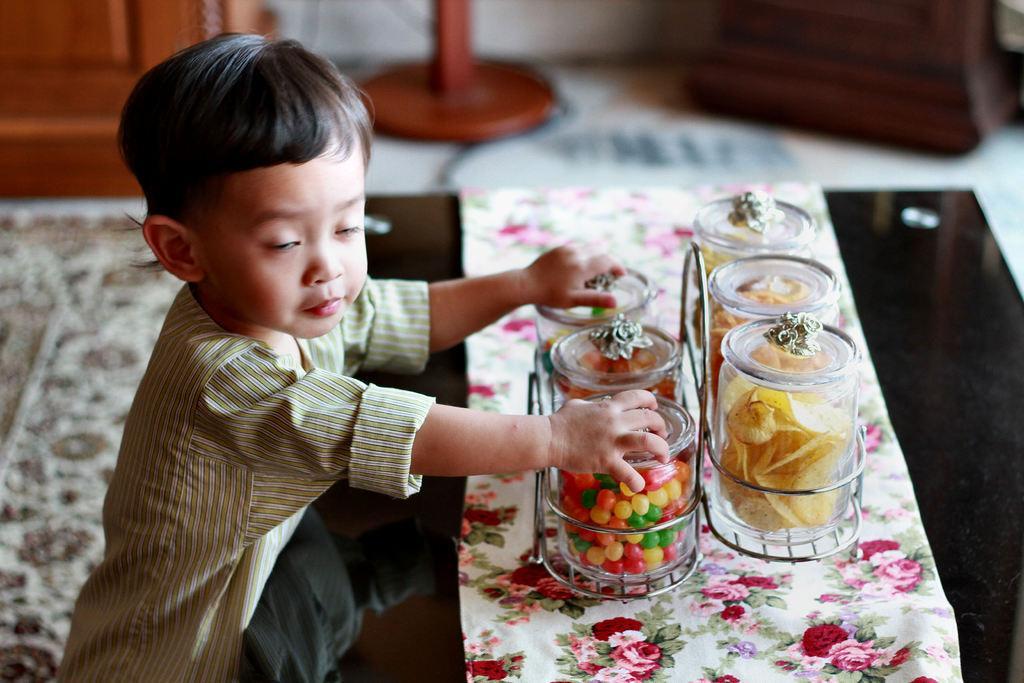Could you give a brief overview of what you see in this image? In the center of the image we can see a kid is holding some objects. In front of him, we can see one black color object. On that object, we can see a cloth and a few jars on a jar stand. In the jars, we can see some food items. In the background there is a wall and a few other objects. 